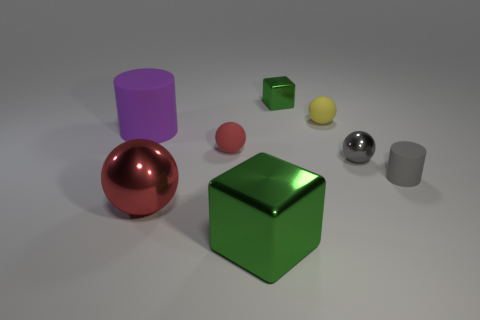Can you describe the lighting and shadows in relation to the objects? The lighting in the image appears to be soft and diffused, coming predominantly from above. It creates soft-edged shadows that are cast directly beneath the objects, suggesting an ambient light source without a strong directional focus. 